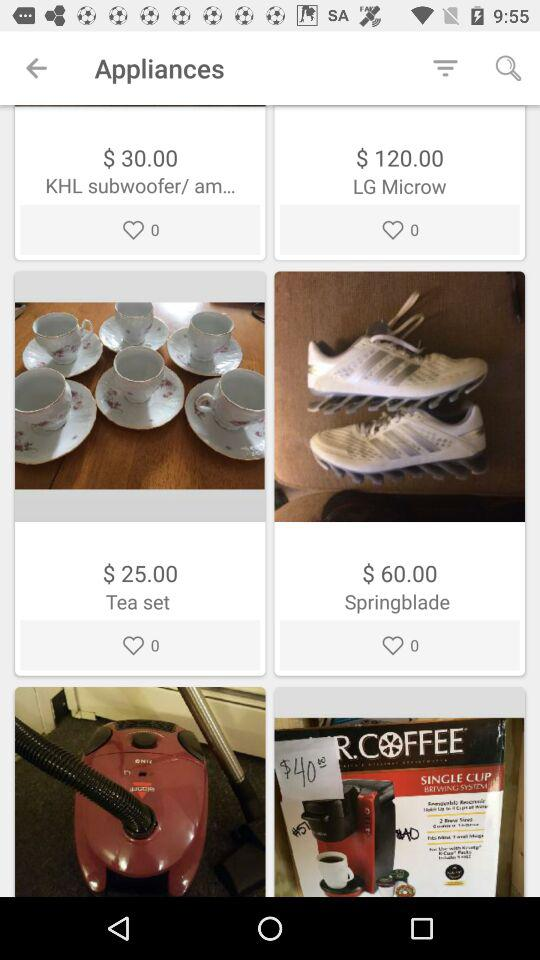How many hearts are there for the tea set? There are 0 hearts for the tea set. 